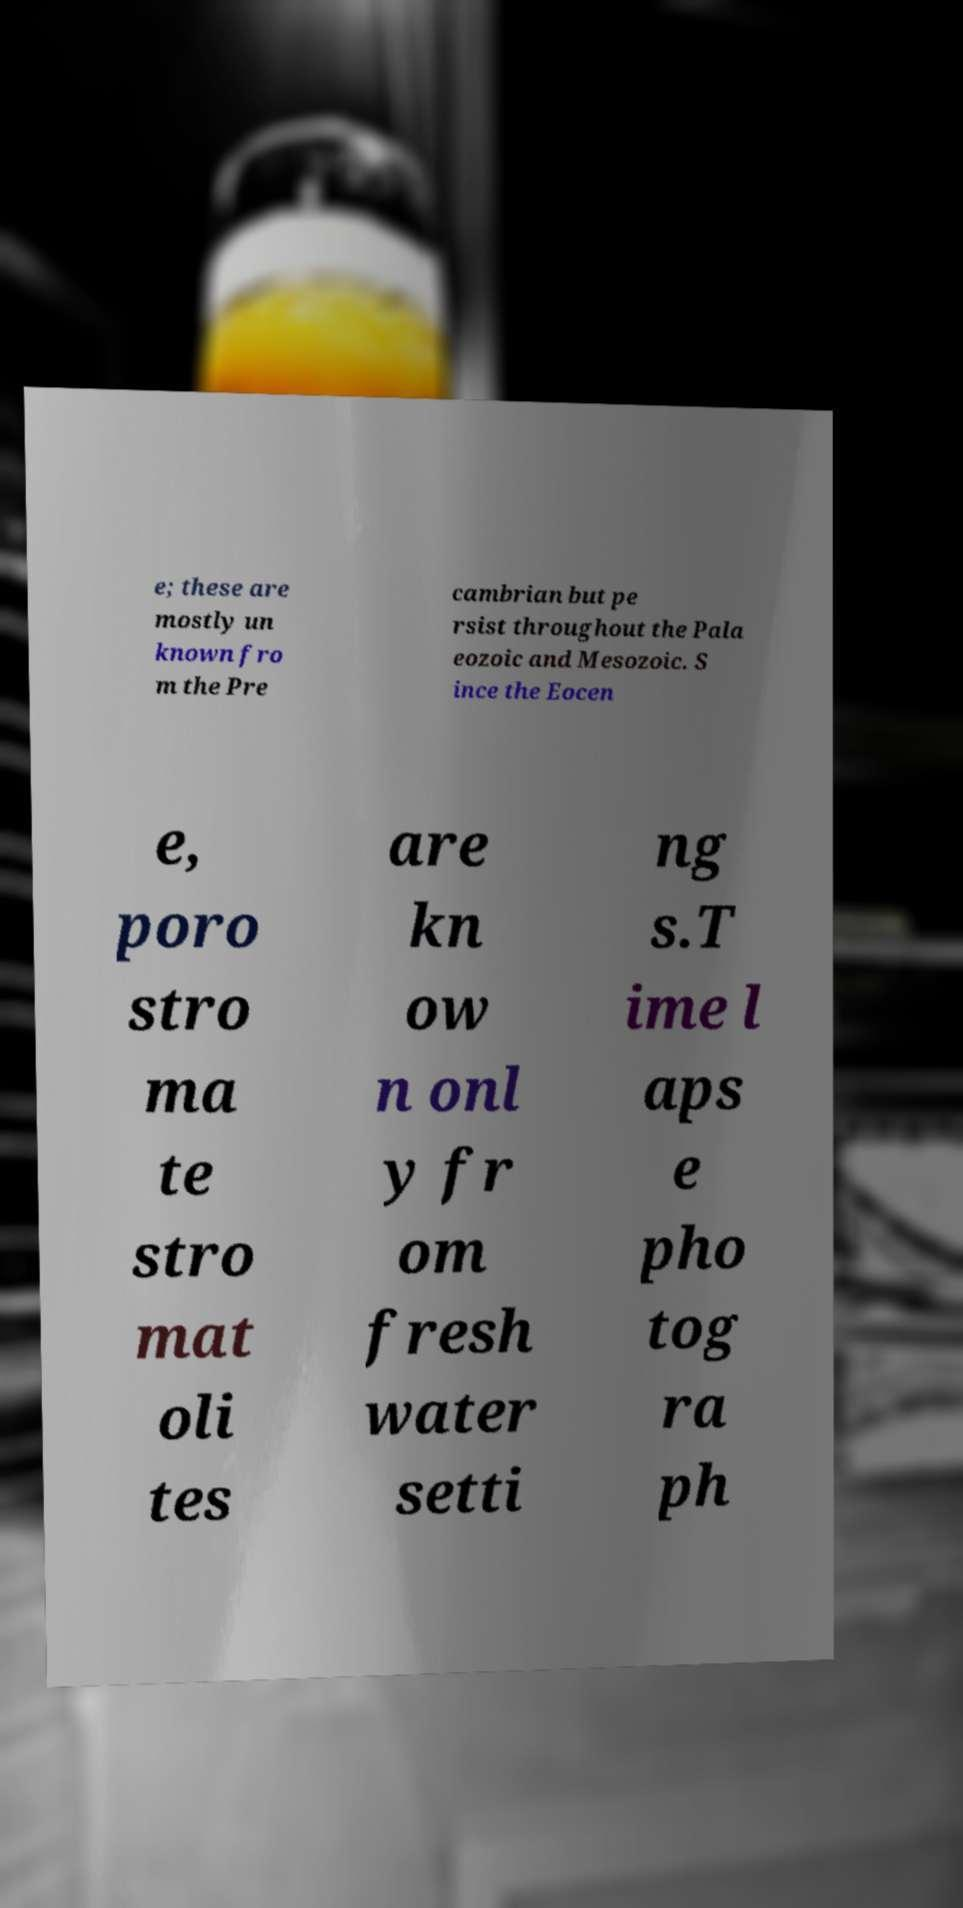There's text embedded in this image that I need extracted. Can you transcribe it verbatim? e; these are mostly un known fro m the Pre cambrian but pe rsist throughout the Pala eozoic and Mesozoic. S ince the Eocen e, poro stro ma te stro mat oli tes are kn ow n onl y fr om fresh water setti ng s.T ime l aps e pho tog ra ph 